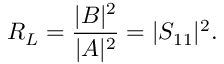Convert formula to latex. <formula><loc_0><loc_0><loc_500><loc_500>R _ { L } = { \frac { | B | ^ { 2 } } { | A | ^ { 2 } } } = | S _ { 1 1 } | ^ { 2 } .</formula> 